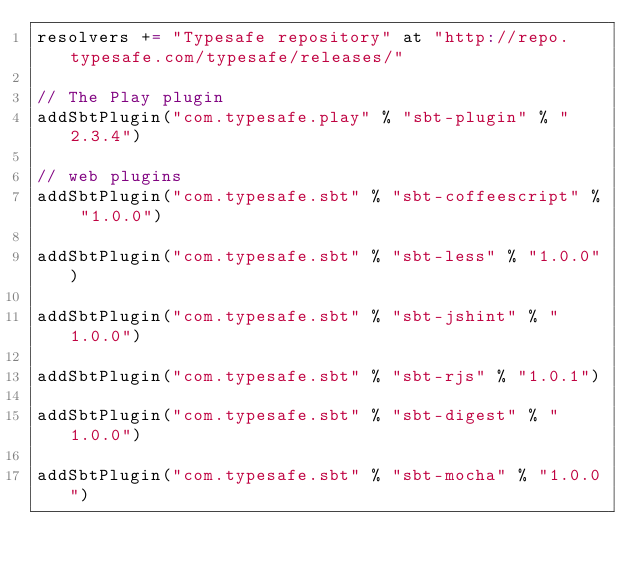Convert code to text. <code><loc_0><loc_0><loc_500><loc_500><_Scala_>resolvers += "Typesafe repository" at "http://repo.typesafe.com/typesafe/releases/"

// The Play plugin
addSbtPlugin("com.typesafe.play" % "sbt-plugin" % "2.3.4")

// web plugins
addSbtPlugin("com.typesafe.sbt" % "sbt-coffeescript" % "1.0.0")

addSbtPlugin("com.typesafe.sbt" % "sbt-less" % "1.0.0")

addSbtPlugin("com.typesafe.sbt" % "sbt-jshint" % "1.0.0")

addSbtPlugin("com.typesafe.sbt" % "sbt-rjs" % "1.0.1")

addSbtPlugin("com.typesafe.sbt" % "sbt-digest" % "1.0.0")

addSbtPlugin("com.typesafe.sbt" % "sbt-mocha" % "1.0.0")</code> 